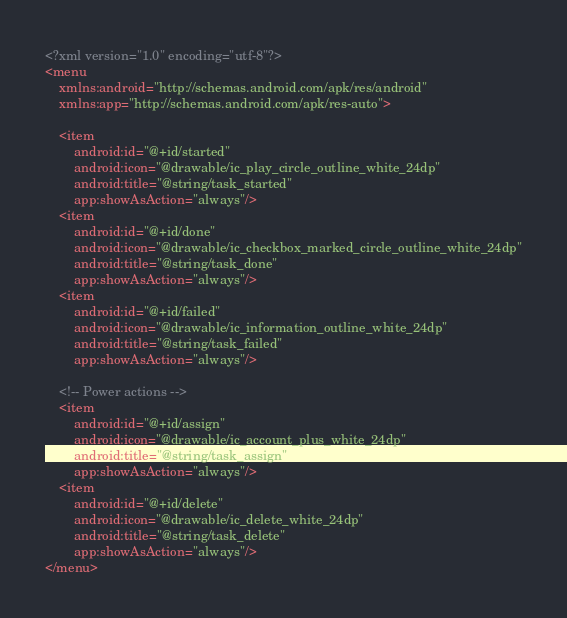<code> <loc_0><loc_0><loc_500><loc_500><_XML_><?xml version="1.0" encoding="utf-8"?>
<menu
    xmlns:android="http://schemas.android.com/apk/res/android"
    xmlns:app="http://schemas.android.com/apk/res-auto">

    <item
        android:id="@+id/started"
        android:icon="@drawable/ic_play_circle_outline_white_24dp"
        android:title="@string/task_started"
        app:showAsAction="always"/>
    <item
        android:id="@+id/done"
        android:icon="@drawable/ic_checkbox_marked_circle_outline_white_24dp"
        android:title="@string/task_done"
        app:showAsAction="always"/>
    <item
        android:id="@+id/failed"
        android:icon="@drawable/ic_information_outline_white_24dp"
        android:title="@string/task_failed"
        app:showAsAction="always"/>

    <!-- Power actions -->
    <item
        android:id="@+id/assign"
        android:icon="@drawable/ic_account_plus_white_24dp"
        android:title="@string/task_assign"
        app:showAsAction="always"/>
    <item
        android:id="@+id/delete"
        android:icon="@drawable/ic_delete_white_24dp"
        android:title="@string/task_delete"
        app:showAsAction="always"/>
</menu>
</code> 